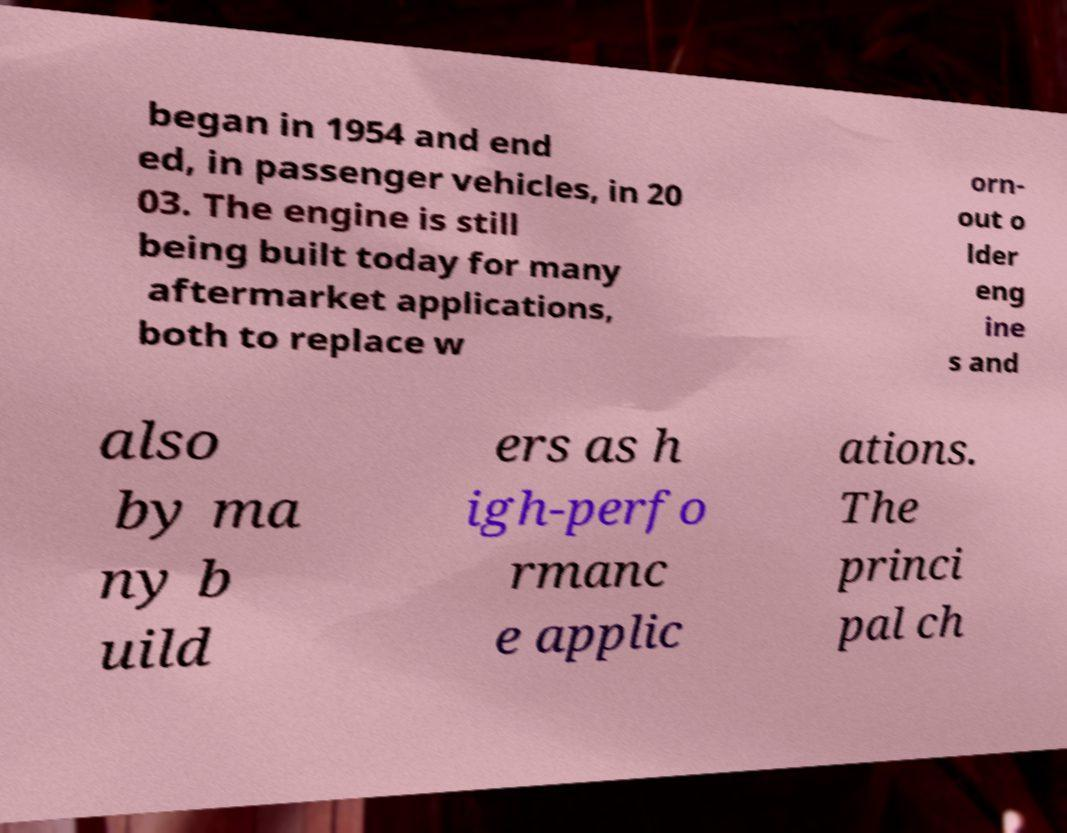I need the written content from this picture converted into text. Can you do that? began in 1954 and end ed, in passenger vehicles, in 20 03. The engine is still being built today for many aftermarket applications, both to replace w orn- out o lder eng ine s and also by ma ny b uild ers as h igh-perfo rmanc e applic ations. The princi pal ch 